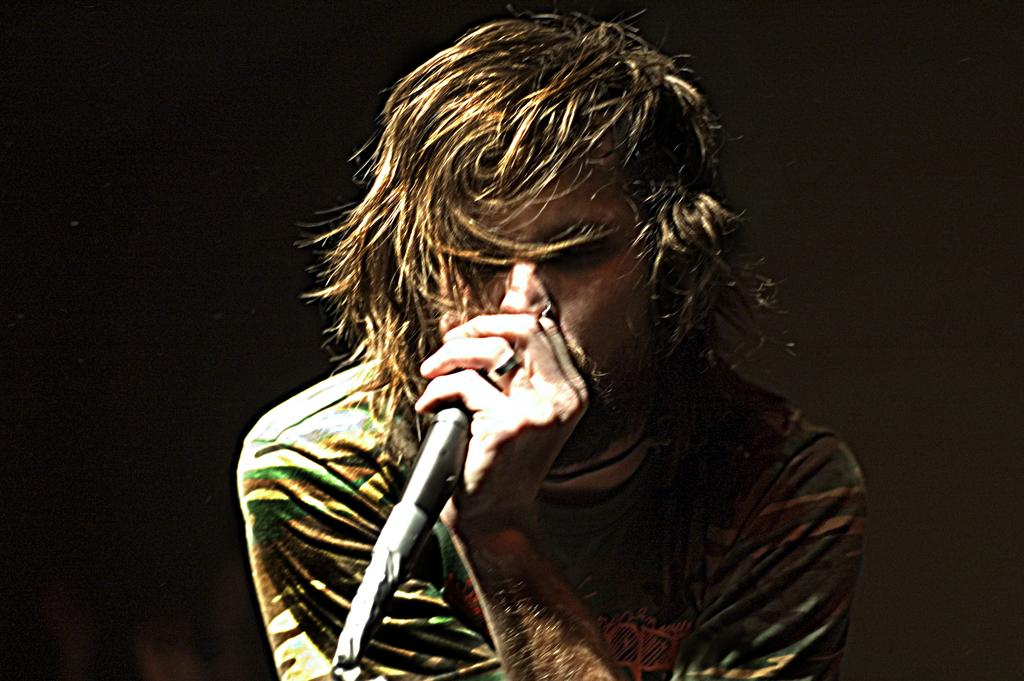Who is the main subject in the image? There is a man in the image. What is the man doing in the image? The man is singing. What object is the man holding in the image? The man is holding a microphone. What color is the background of the image? The background of the image is black. What type of scent can be detected in the image? There is no mention of a scent in the image, so it cannot be determined from the image. 